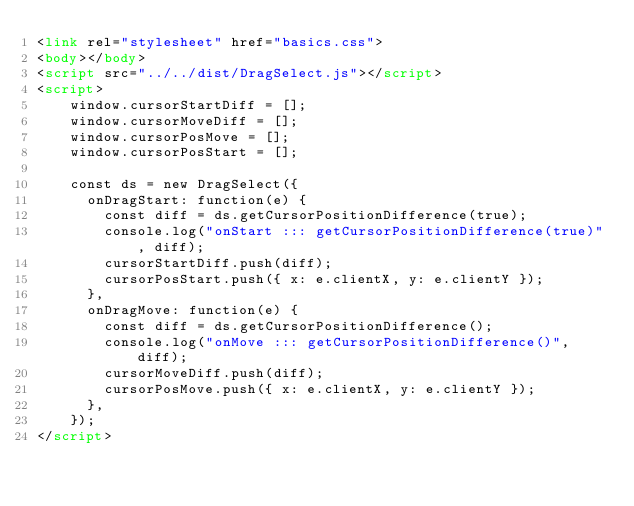Convert code to text. <code><loc_0><loc_0><loc_500><loc_500><_HTML_><link rel="stylesheet" href="basics.css">
<body></body>
<script src="../../dist/DragSelect.js"></script>
<script>
    window.cursorStartDiff = [];
    window.cursorMoveDiff = [];
    window.cursorPosMove = [];
    window.cursorPosStart = [];

    const ds = new DragSelect({
      onDragStart: function(e) {
        const diff = ds.getCursorPositionDifference(true);
        console.log("onStart ::: getCursorPositionDifference(true)", diff);
        cursorStartDiff.push(diff);
        cursorPosStart.push({ x: e.clientX, y: e.clientY });
      },
      onDragMove: function(e) {
        const diff = ds.getCursorPositionDifference();
        console.log("onMove ::: getCursorPositionDifference()", diff);
        cursorMoveDiff.push(diff);
        cursorPosMove.push({ x: e.clientX, y: e.clientY });
      },
    });
</script>
</code> 